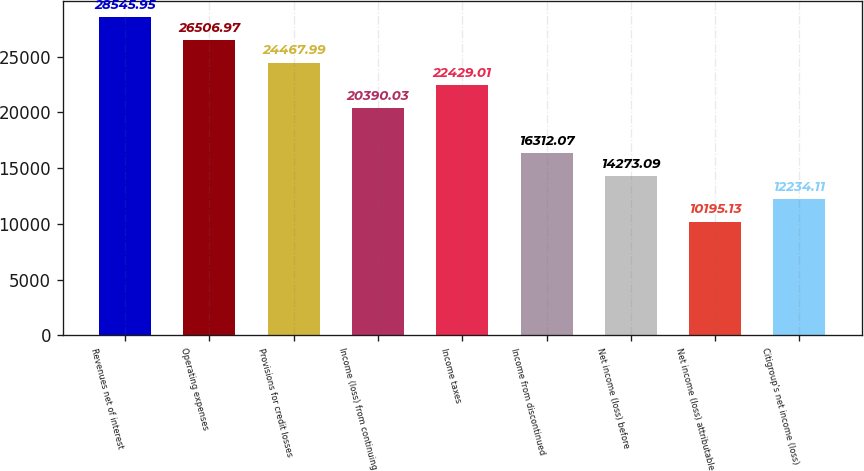Convert chart. <chart><loc_0><loc_0><loc_500><loc_500><bar_chart><fcel>Revenues net of interest<fcel>Operating expenses<fcel>Provisions for credit losses<fcel>Income (loss) from continuing<fcel>Income taxes<fcel>Income from discontinued<fcel>Net income (loss) before<fcel>Net income (loss) attributable<fcel>Citigroup's net income (loss)<nl><fcel>28546<fcel>26507<fcel>24468<fcel>20390<fcel>22429<fcel>16312.1<fcel>14273.1<fcel>10195.1<fcel>12234.1<nl></chart> 